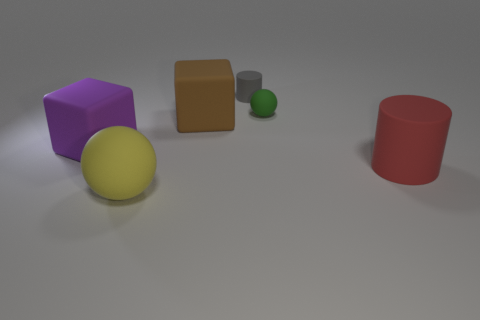Is the size of the gray object the same as the green ball?
Your answer should be compact. Yes. How many tiny spheres are behind the tiny green sphere?
Offer a very short reply. 0. What number of objects are either spheres that are on the right side of the big brown matte object or small green shiny cylinders?
Ensure brevity in your answer.  1. Are there more yellow balls on the right side of the brown matte block than things to the right of the green ball?
Offer a terse response. No. Do the gray object and the ball that is in front of the red matte cylinder have the same size?
Give a very brief answer. No. What number of spheres are tiny gray objects or green matte objects?
Offer a very short reply. 1. What size is the yellow sphere that is made of the same material as the big red object?
Your answer should be very brief. Large. There is a rubber cylinder that is in front of the tiny gray rubber object; is it the same size as the rubber cube that is in front of the large brown block?
Provide a short and direct response. Yes. How many objects are either matte spheres or small matte objects?
Your answer should be compact. 3. There is a large yellow object; what shape is it?
Your answer should be compact. Sphere. 